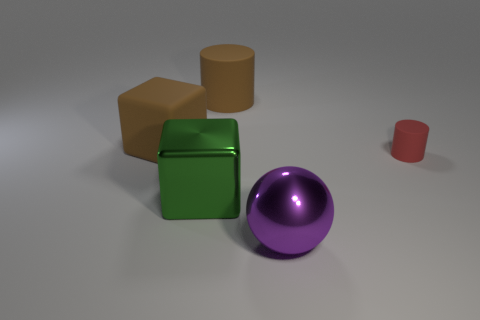What is the shape of the purple object that is the same size as the green cube? sphere 